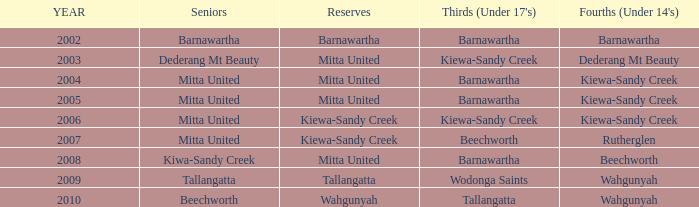Which Thirds (Under 17's) have a Reserve of barnawartha? Barnawartha. 